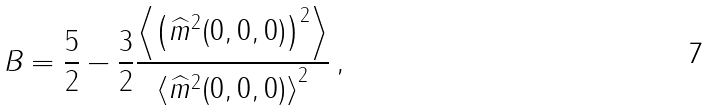Convert formula to latex. <formula><loc_0><loc_0><loc_500><loc_500>B = \frac { 5 } { 2 } - \frac { 3 } { 2 } \frac { \left \langle \left ( \widehat { m } ^ { 2 } ( 0 , 0 , 0 ) \right ) ^ { 2 } \right \rangle } { \left \langle \widehat { m } ^ { 2 } ( 0 , 0 , 0 ) \right \rangle ^ { 2 } } \, ,</formula> 